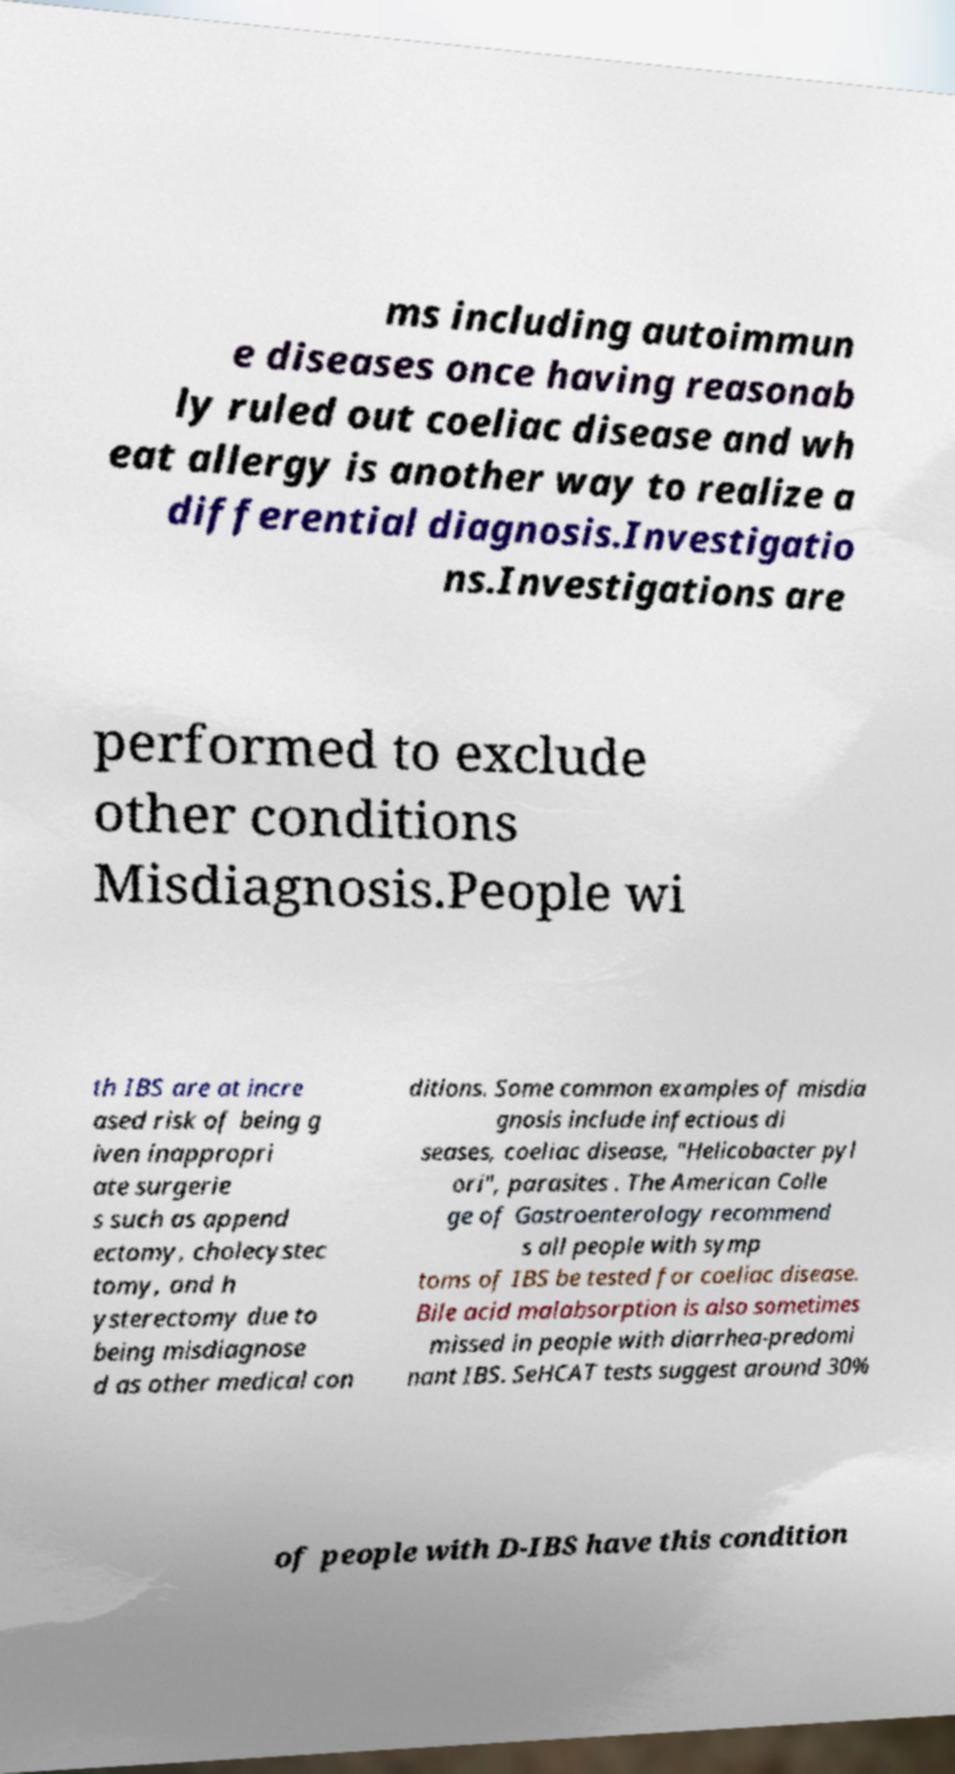Can you accurately transcribe the text from the provided image for me? ms including autoimmun e diseases once having reasonab ly ruled out coeliac disease and wh eat allergy is another way to realize a differential diagnosis.Investigatio ns.Investigations are performed to exclude other conditions Misdiagnosis.People wi th IBS are at incre ased risk of being g iven inappropri ate surgerie s such as append ectomy, cholecystec tomy, and h ysterectomy due to being misdiagnose d as other medical con ditions. Some common examples of misdia gnosis include infectious di seases, coeliac disease, "Helicobacter pyl ori", parasites . The American Colle ge of Gastroenterology recommend s all people with symp toms of IBS be tested for coeliac disease. Bile acid malabsorption is also sometimes missed in people with diarrhea-predomi nant IBS. SeHCAT tests suggest around 30% of people with D-IBS have this condition 